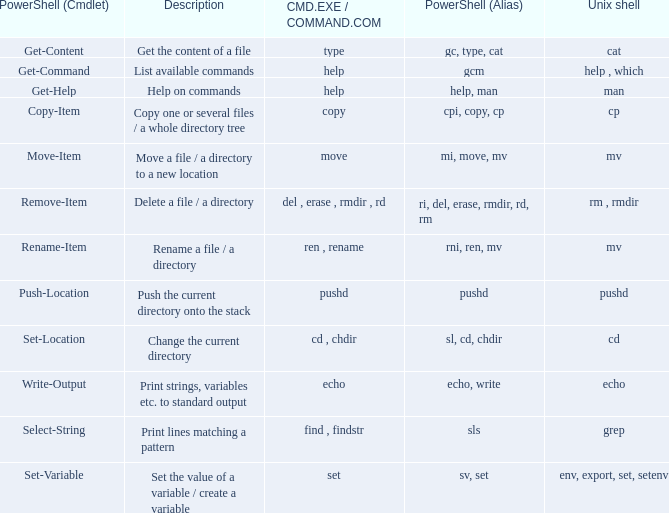What are the names of all unix shell with PowerShell (Cmdlet) of select-string? Grep. 